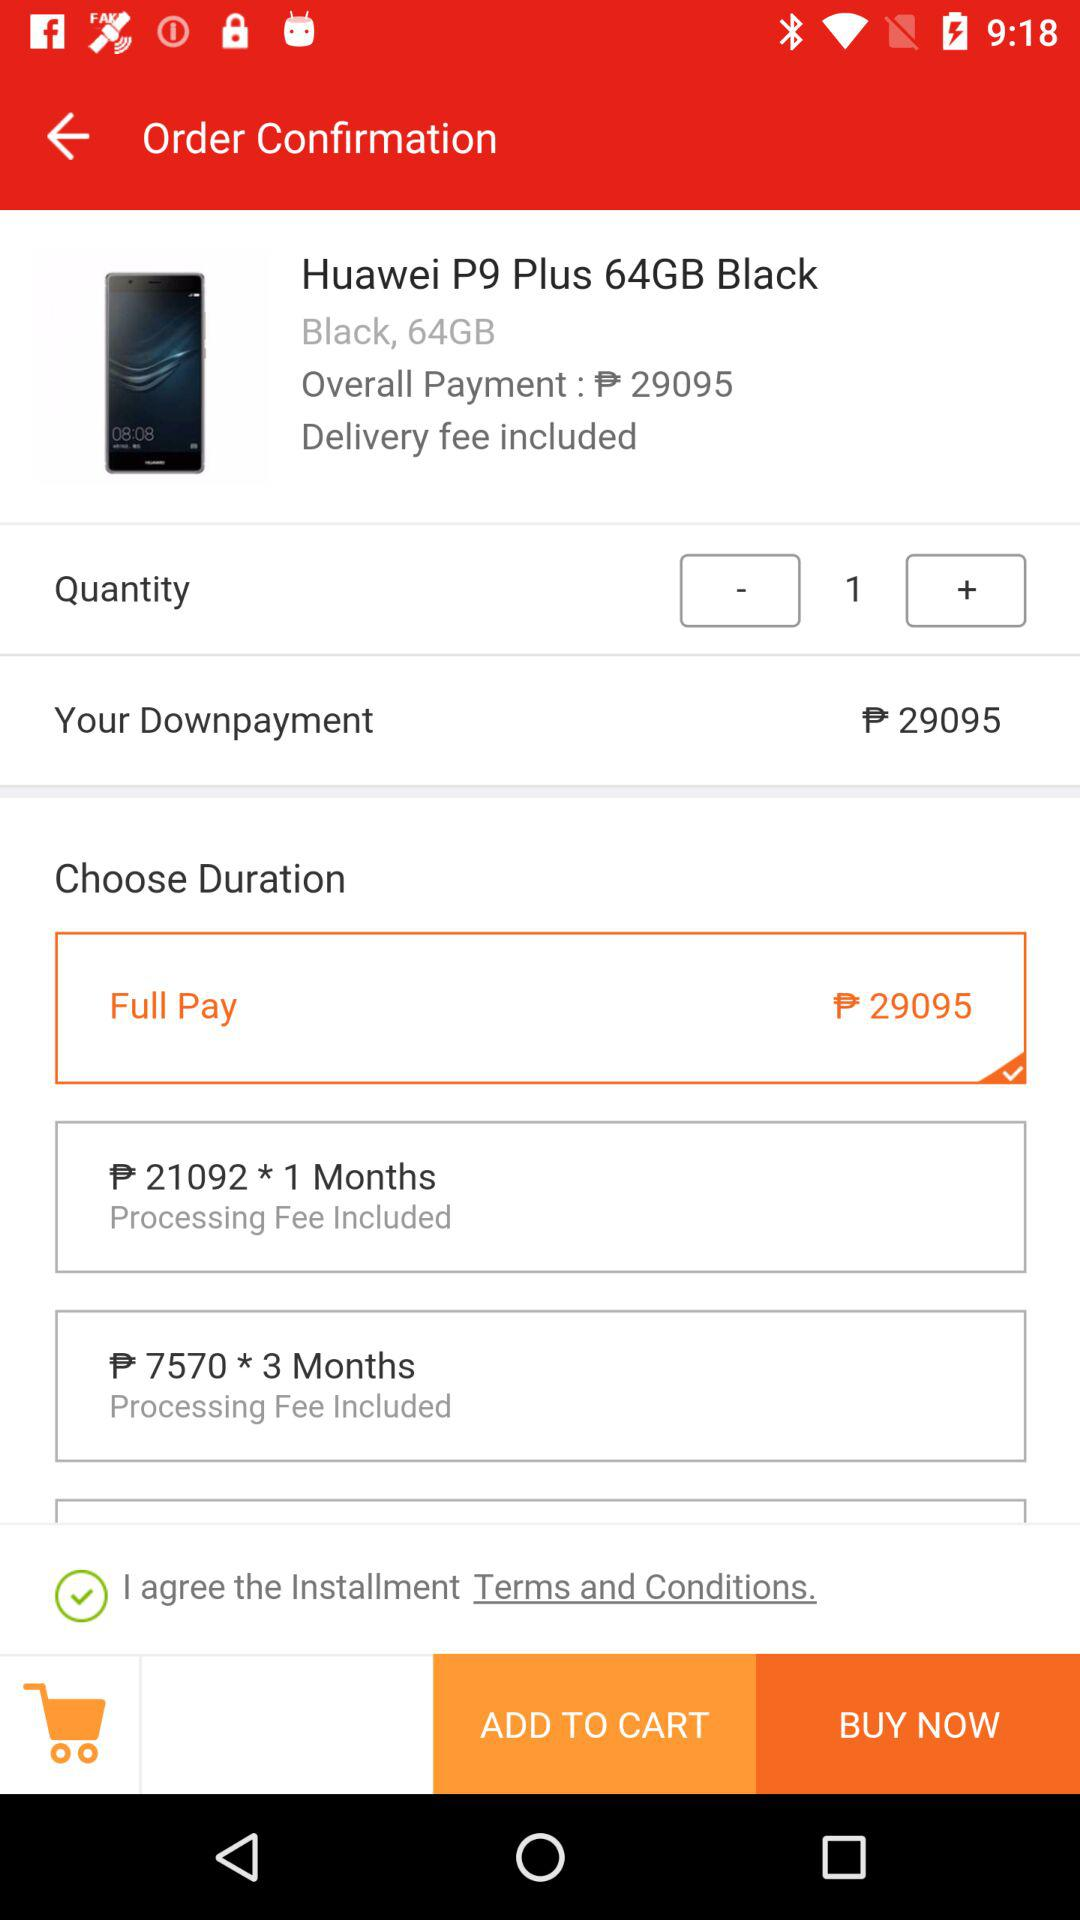What is the quantity of the product? The quantity of the product is 1. 